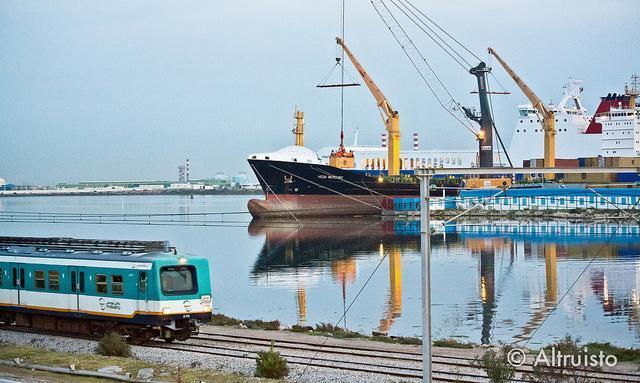How many trains are in the picture?
Give a very brief answer. 1. How many train cars have some yellow on them?
Give a very brief answer. 0. 